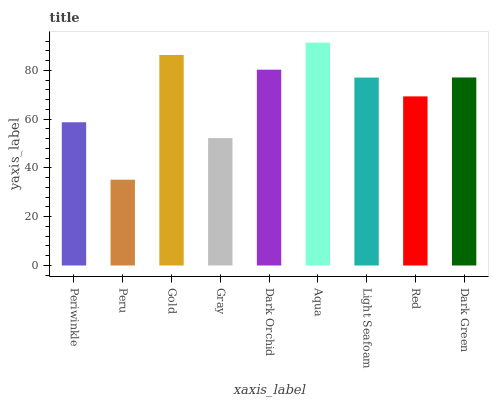Is Peru the minimum?
Answer yes or no. Yes. Is Aqua the maximum?
Answer yes or no. Yes. Is Gold the minimum?
Answer yes or no. No. Is Gold the maximum?
Answer yes or no. No. Is Gold greater than Peru?
Answer yes or no. Yes. Is Peru less than Gold?
Answer yes or no. Yes. Is Peru greater than Gold?
Answer yes or no. No. Is Gold less than Peru?
Answer yes or no. No. Is Light Seafoam the high median?
Answer yes or no. Yes. Is Light Seafoam the low median?
Answer yes or no. Yes. Is Red the high median?
Answer yes or no. No. Is Dark Green the low median?
Answer yes or no. No. 